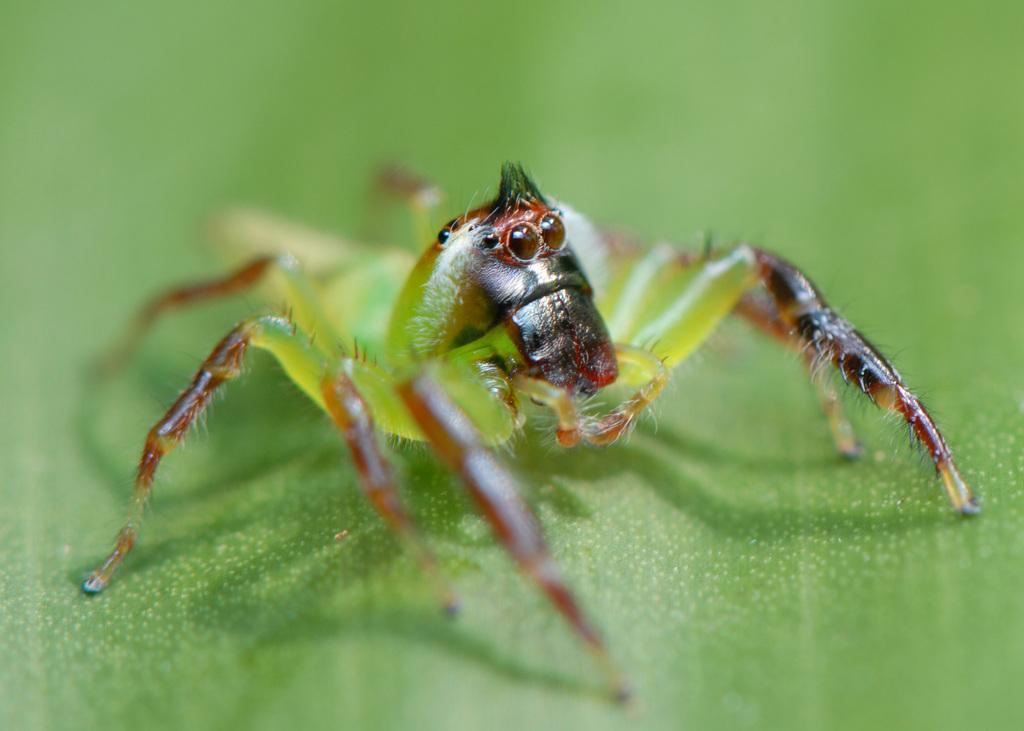Please provide a concise description of this image. There is an insect on a greenery surface. 